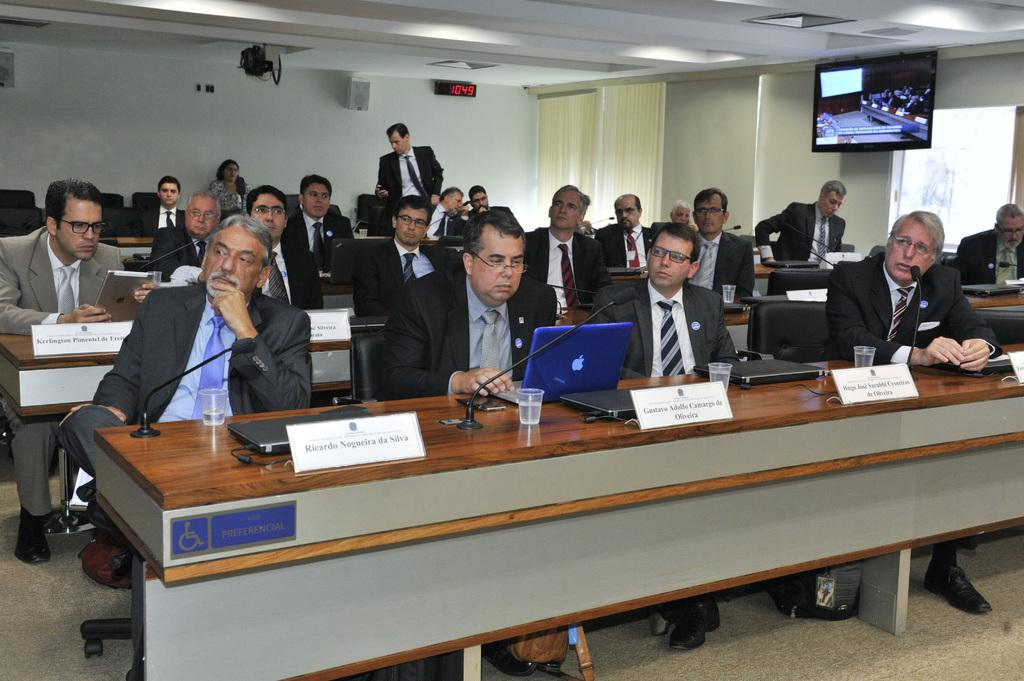What are the people in the image doing? The people in the image are sitting on chairs. What electronic devices can be seen in the image? There are laptops visible in the image. What objects are present on the tables in the image? There are microphones (mics) on the tables in the image. How many writers are present in the image? There is no mention of writers in the image; it only shows people sitting on chairs and laptops and microphones on the tables. 